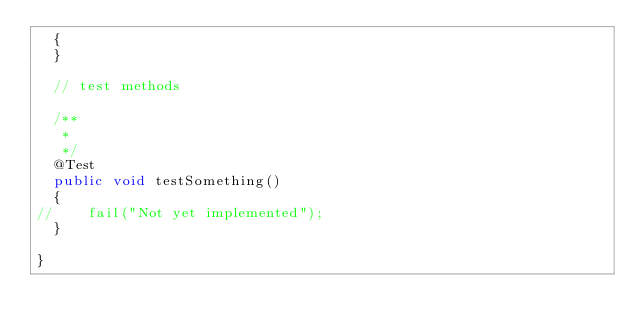<code> <loc_0><loc_0><loc_500><loc_500><_Java_>	{
	}
	
	// test methods
	
	/**
	 * 
	 */
	@Test
	public void testSomething()
	{
//		fail("Not yet implemented");
	}
	
}
</code> 